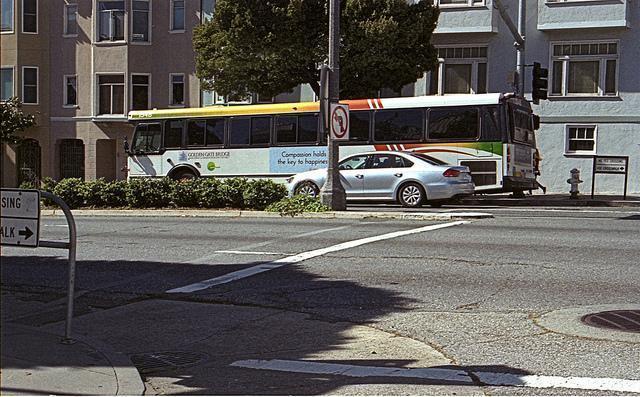What is the car next to?
Choose the right answer from the provided options to respond to the question.
Options: Elephant, airplane, bus, giraffe. Bus. 